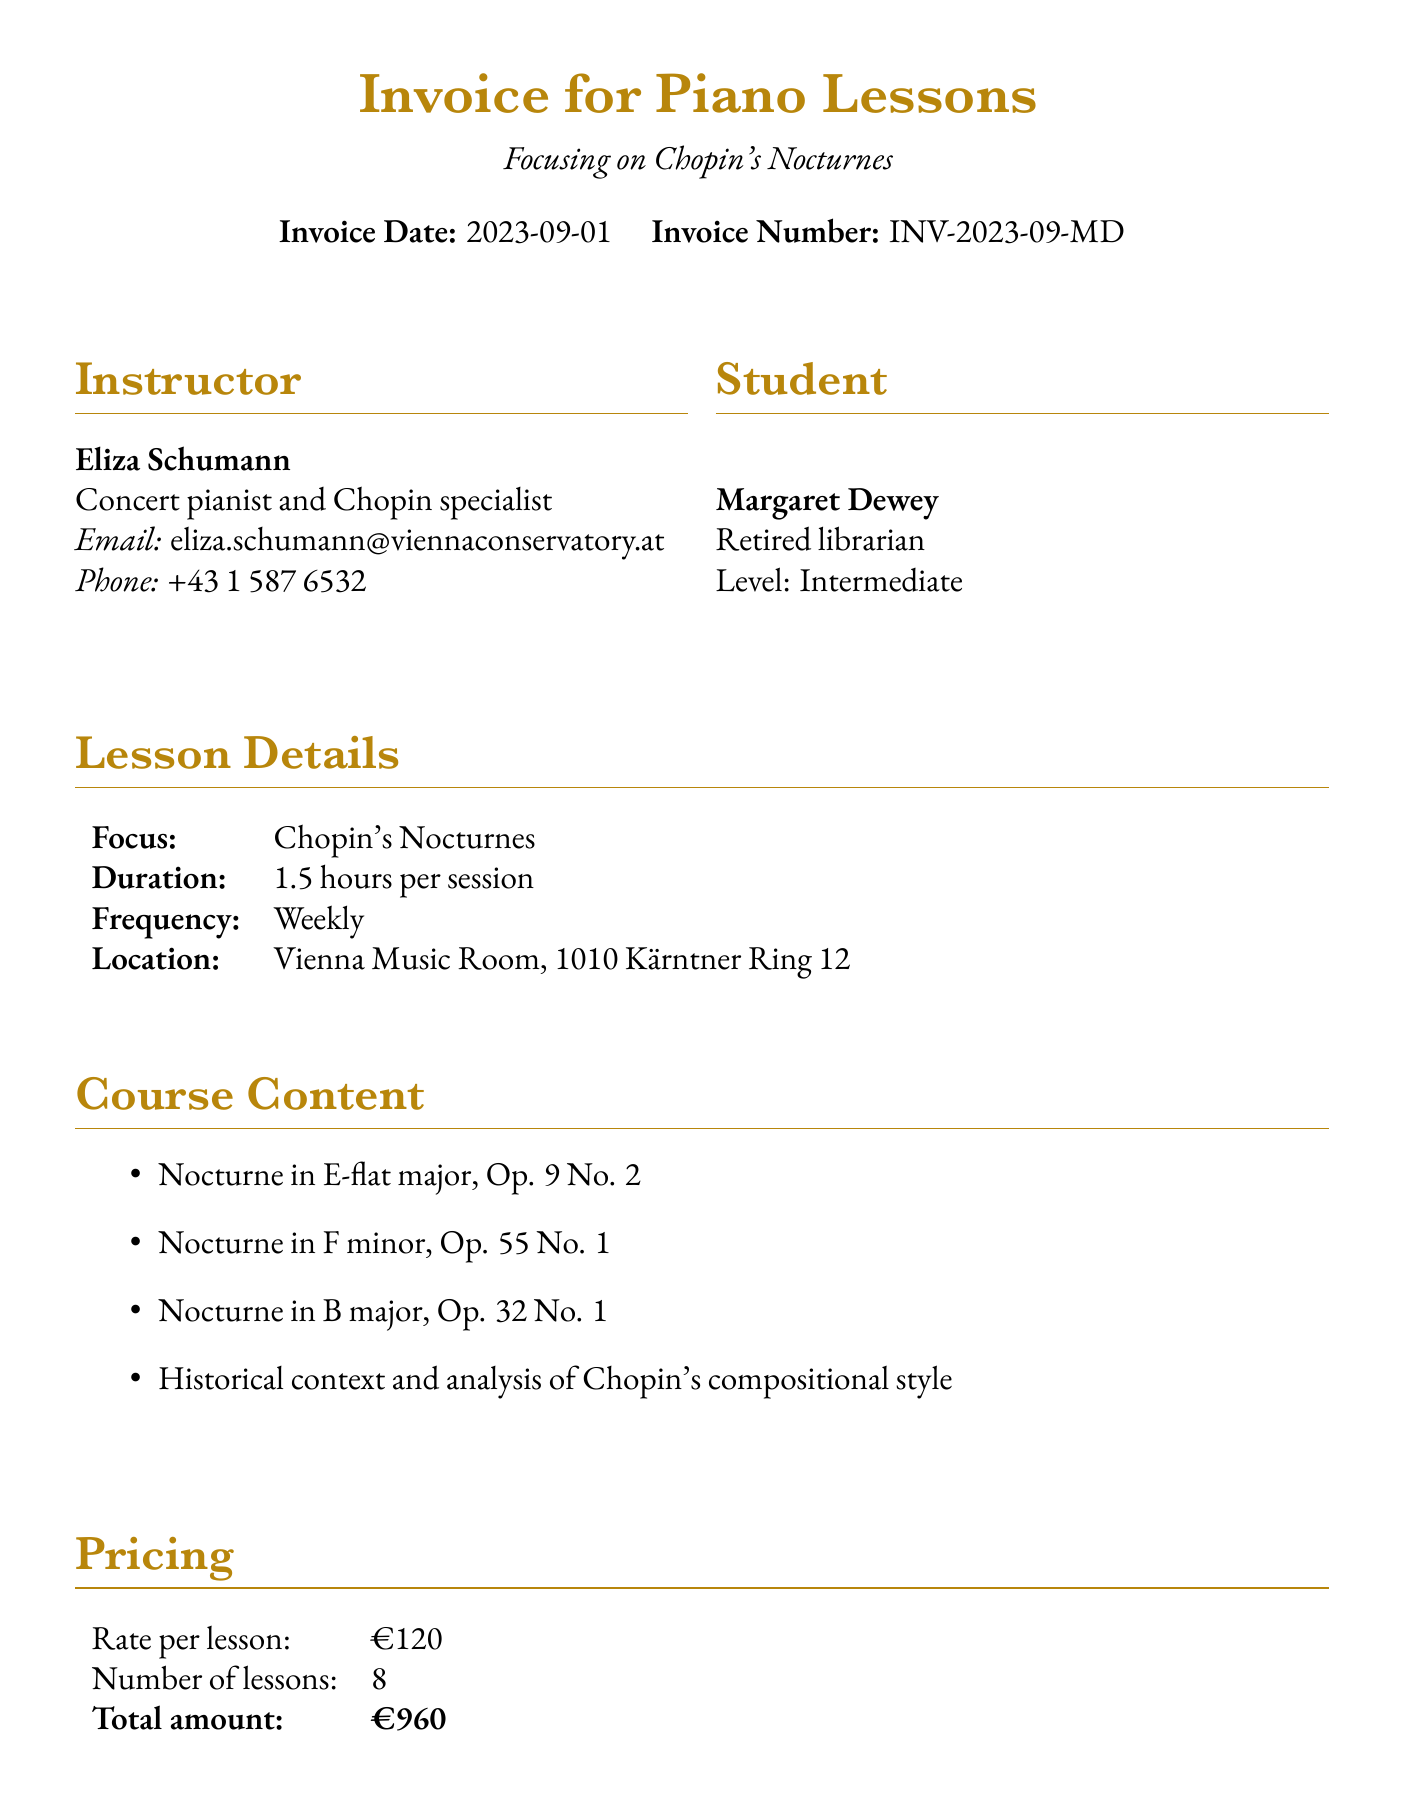What is the name of the instructor? The instructor's name is clearly mentioned in the document.
Answer: Eliza Schumann What is the total amount for the lessons? The total amount is provided under the pricing section of the document.
Answer: €960 How many lessons are included in the course? This information is found in the pricing section, indicating the number of lessons.
Answer: 8 What is the focus of the lessons? The focus of the lessons is stated in the lesson details section.
Answer: Chopin's Nocturnes What is the email address of the instructor? The instructor's contact email is specified in the contact details.
Answer: eliza.schumann@viennaconservatory.at What is the cancellation policy? The cancellation policy is detailed as a requirement in the document.
Answer: 48-hour notice required for lesson cancellation without charge What additional service is offered related to sheet music? This information is provided in the additional services section, specifying the title and price.
Answer: Chopin: The Complete Nocturnes (Henle Urtext Edition) What is the frequency of the lessons? The document lists the frequency of the lessons in the lesson details section.
Answer: Weekly When is the concert event mentioned? The date of the concert event is mentioned in the additional services section.
Answer: 2023-11-15 